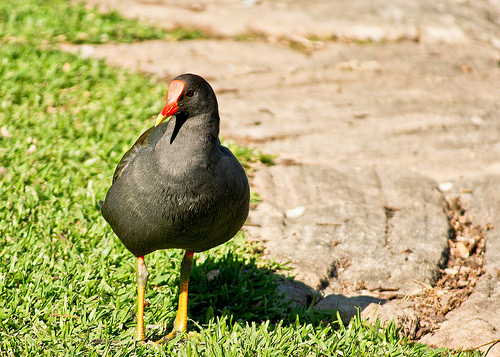<image>
Is the beak behind the chicken feet? No. The beak is not behind the chicken feet. From this viewpoint, the beak appears to be positioned elsewhere in the scene. 